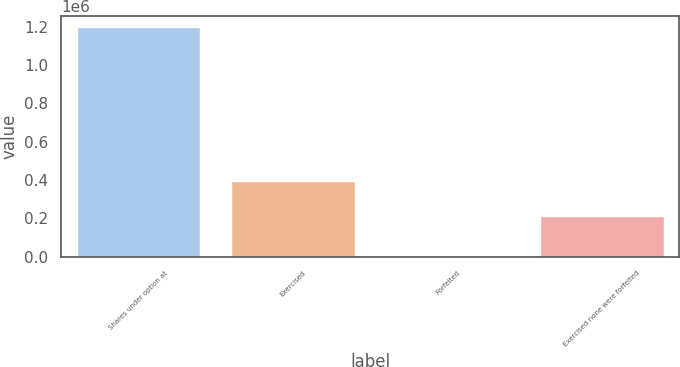<chart> <loc_0><loc_0><loc_500><loc_500><bar_chart><fcel>Shares under option at<fcel>Exercised<fcel>Forfeited<fcel>Exercised none were forfeited<nl><fcel>1.19826e+06<fcel>396659<fcel>3000<fcel>214525<nl></chart> 